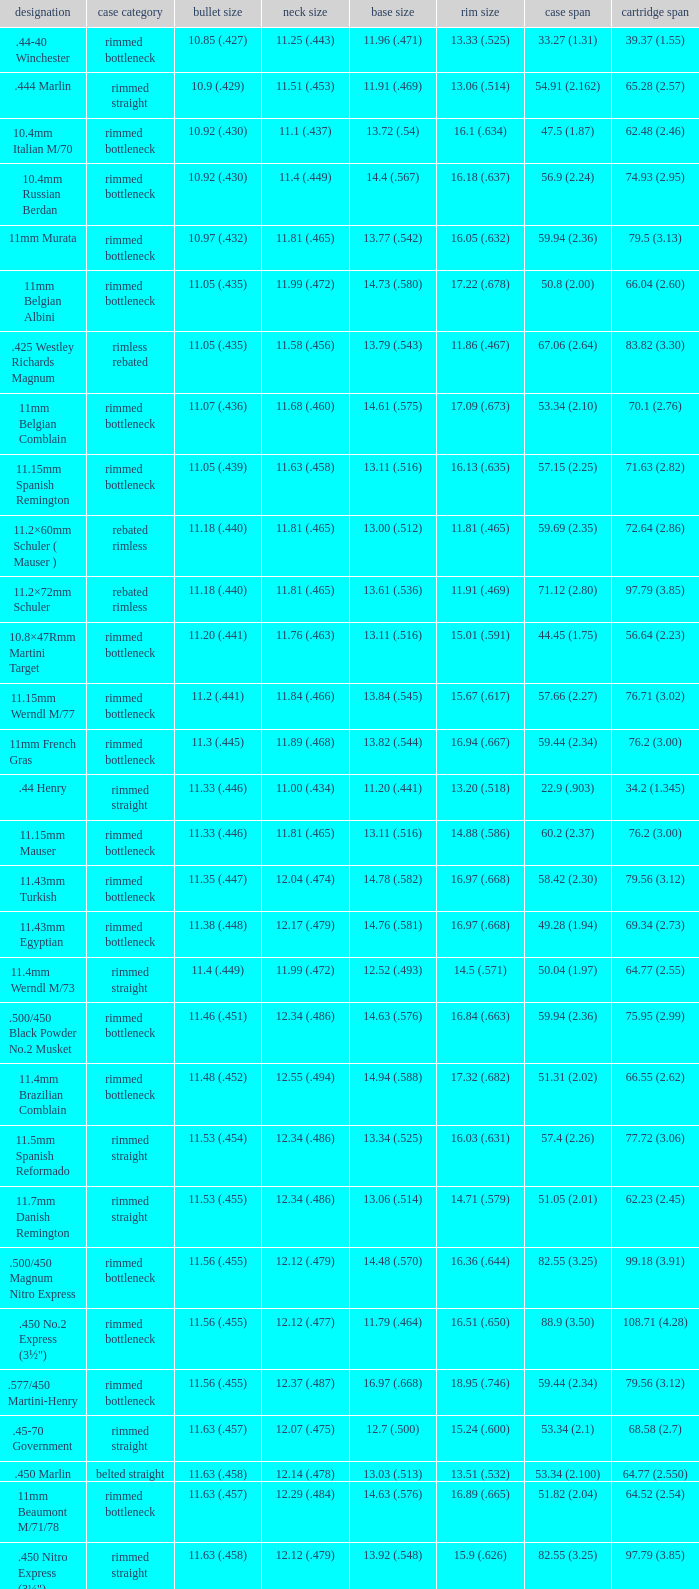Which Rim diameter has a Neck diameter of 11.84 (.466)? 15.67 (.617). 